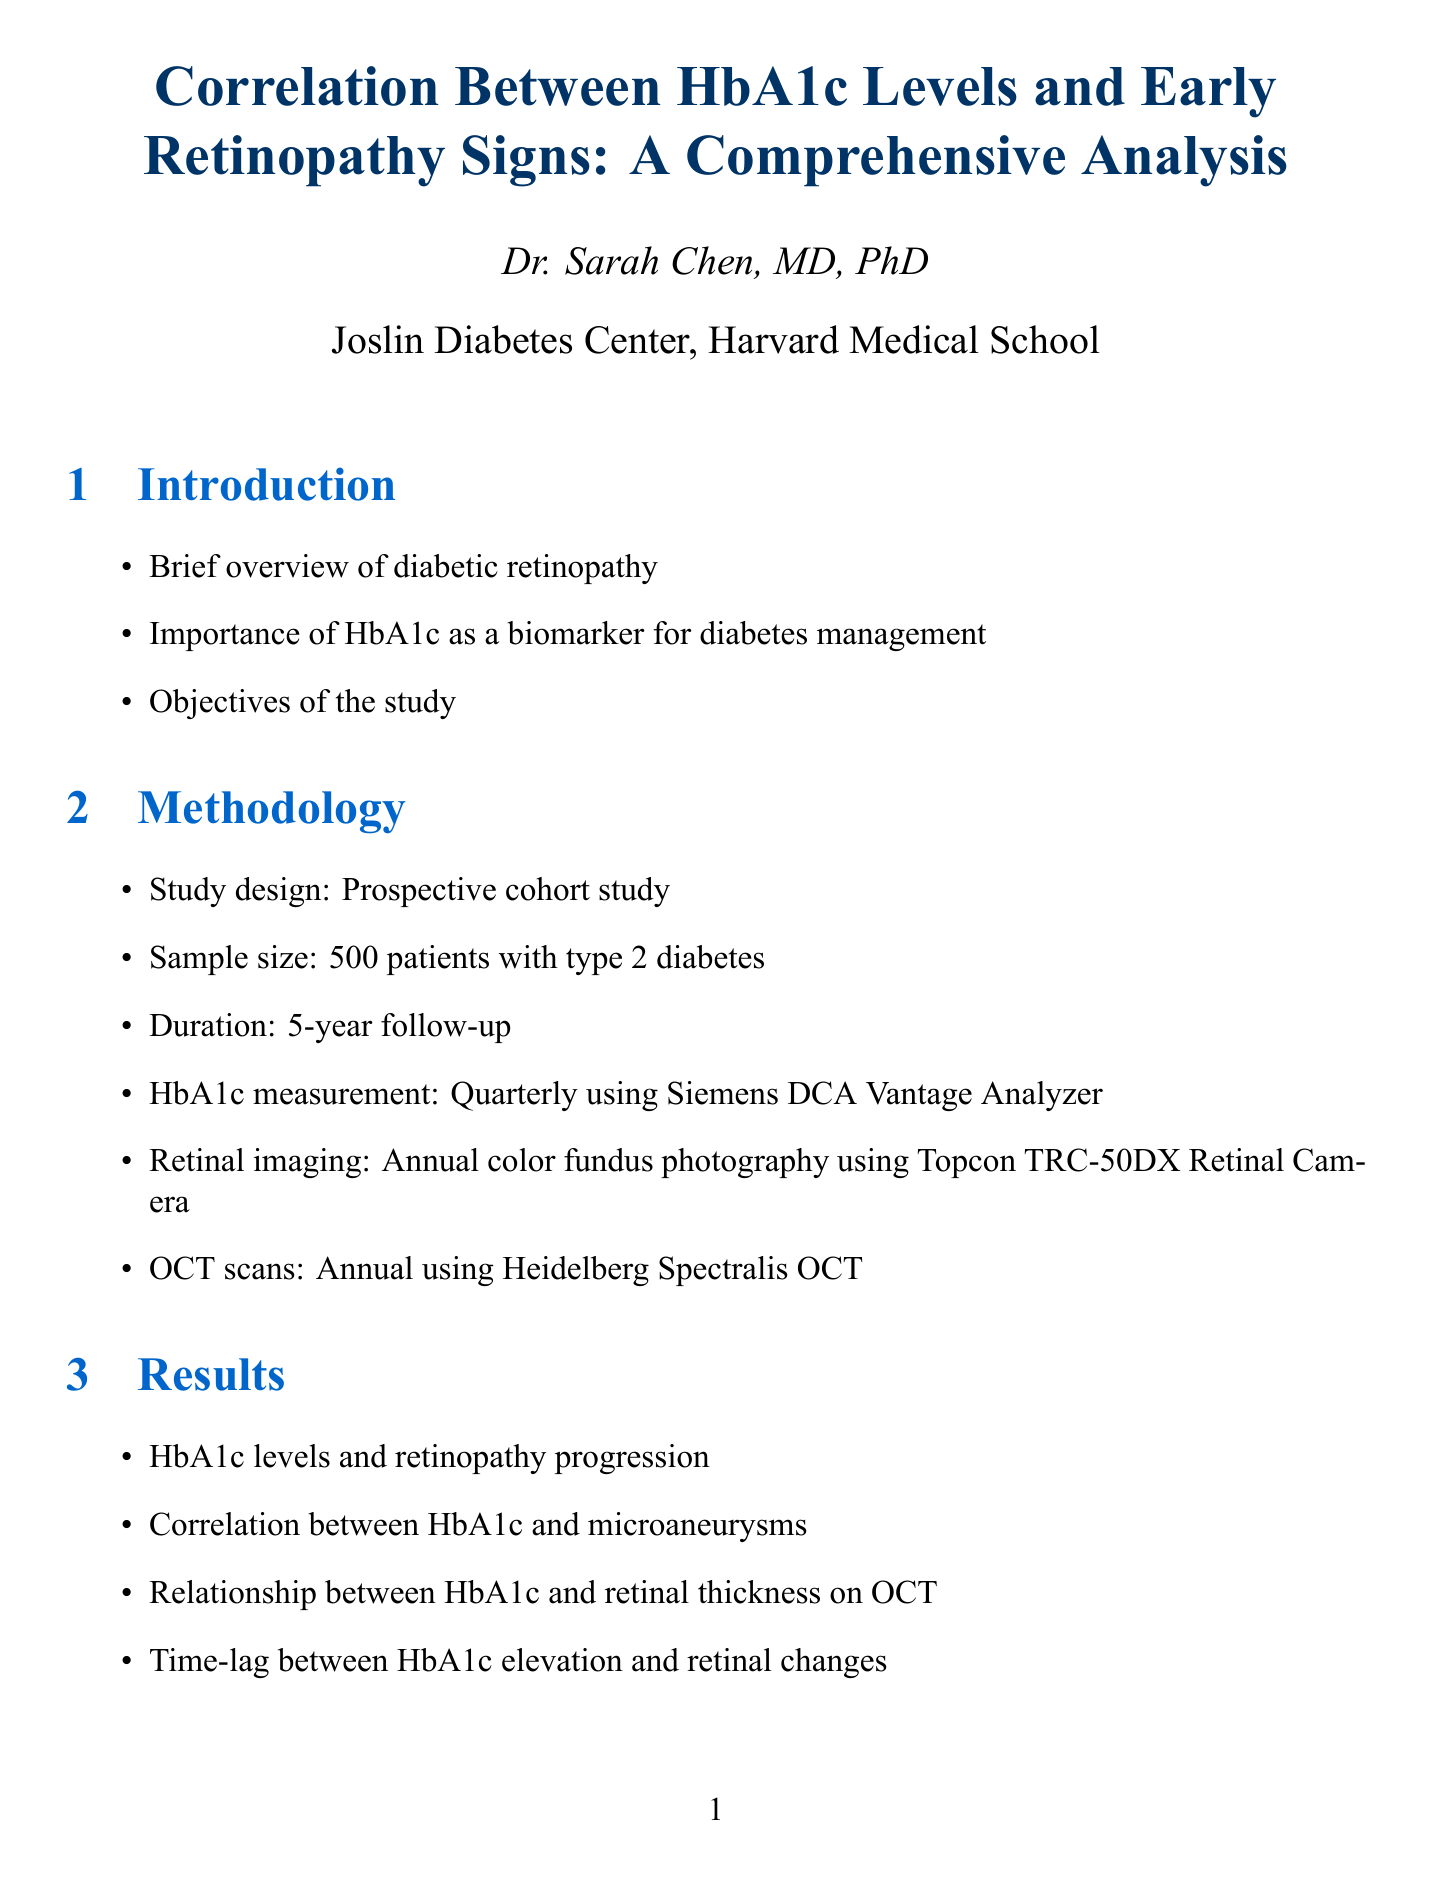What is the title of the report? The title of the report is stated at the beginning of the document.
Answer: Correlation Between HbA1c Levels and Early Retinopathy Signs: A Comprehensive Analysis Who is the author of the report? The author is specified in the title section of the document.
Answer: Dr. Sarah Chen, MD, PhD What is the sample size of the study? The sample size is mentioned in the methodology section of the document.
Answer: 500 patients What is the mean duration of diabetes in years? The mean duration is presented in Table 1, which outlines baseline characteristics.
Answer: 7.2 ± 4.5 What percentage of participants had HbA1c levels greater than 8.0% and showed microaneurysms? The percentage is found in Table 2, which shows incidence by HbA1c category.
Answer: 28.9 According to the report, what imaging technique was used annually alongside color fundus photography? The report lists imaging techniques in the methodology section.
Answer: OCT scans What were the clinical implications emphasized in the discussion section? The discussion outlines various clinical implications of the study results.
Answer: Regular screening and HbA1c control What is the mean baseline HbA1c percentage among study participants? The mean baseline HbA1c is presented in Table 1.
Answer: 7.8 ± 1.2 How many figures are included in the report? The visuals are listed towards the end of the document; each figure correlates with findings.
Answer: 3 